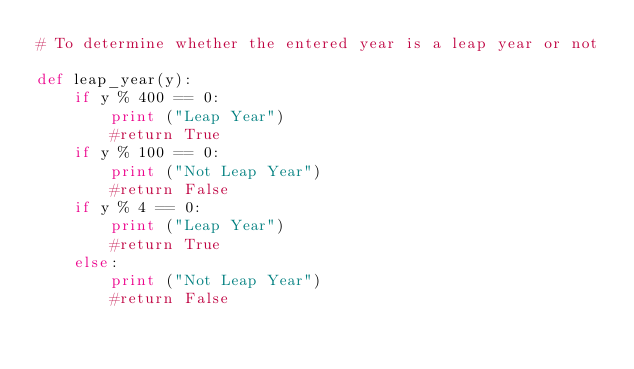<code> <loc_0><loc_0><loc_500><loc_500><_Python_># To determine whether the entered year is a leap year or not

def leap_year(y):
    if y % 400 == 0:
        print ("Leap Year")
        #return True
    if y % 100 == 0:
        print ("Not Leap Year")
        #return False
    if y % 4 == 0:
        print ("Leap Year")
        #return True
    else:
        print ("Not Leap Year")
        #return False
</code> 